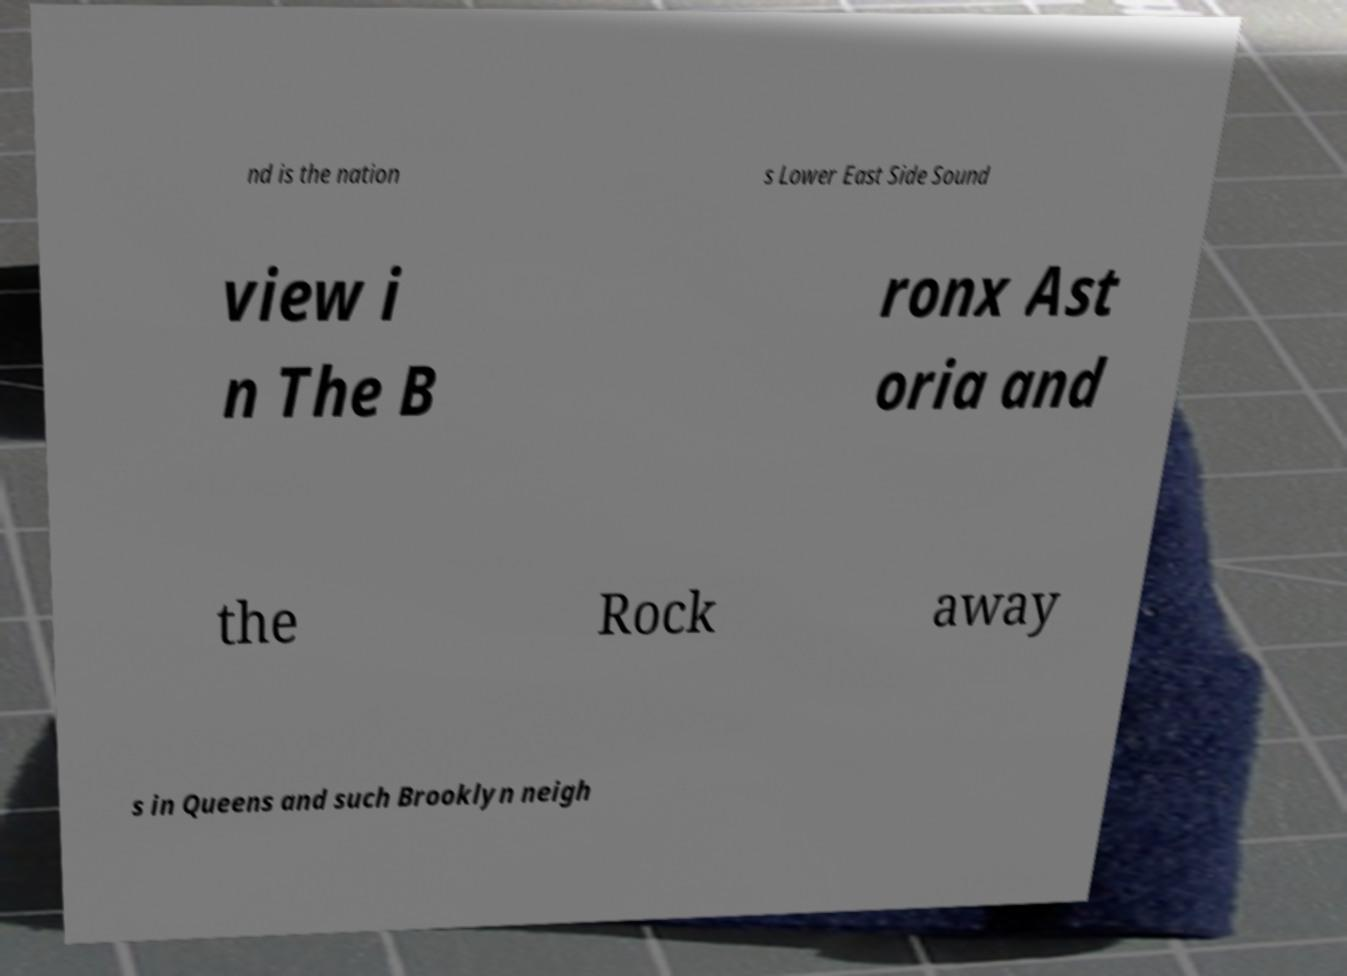Could you assist in decoding the text presented in this image and type it out clearly? nd is the nation s Lower East Side Sound view i n The B ronx Ast oria and the Rock away s in Queens and such Brooklyn neigh 